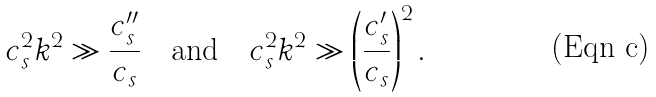Convert formula to latex. <formula><loc_0><loc_0><loc_500><loc_500>c _ { s } ^ { 2 } k ^ { 2 } \gg \frac { c _ { s } ^ { \prime \prime } } { c _ { s } } \quad \text {and} \quad c _ { s } ^ { 2 } k ^ { 2 } \gg \left ( \frac { c _ { s } ^ { \prime } } { c _ { s } } \right ) ^ { 2 } .</formula> 